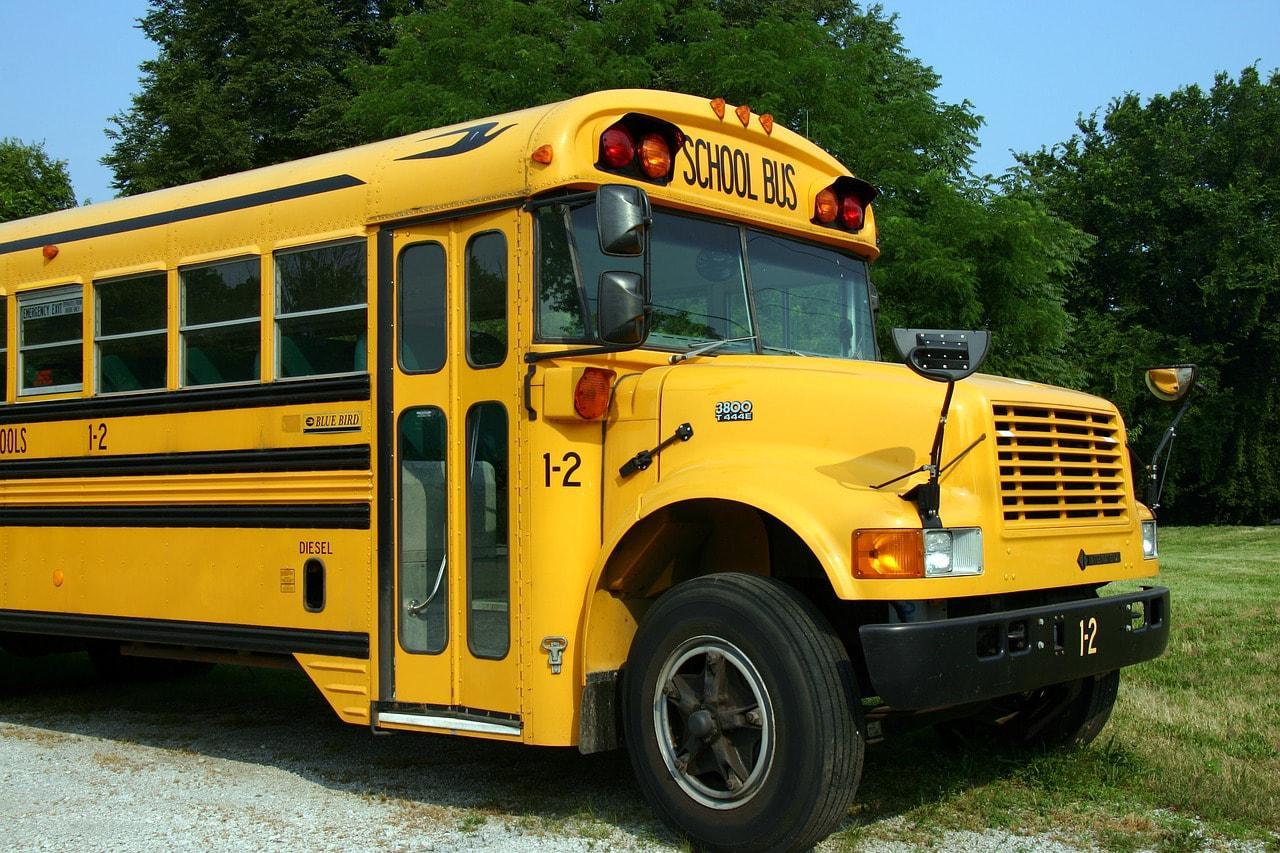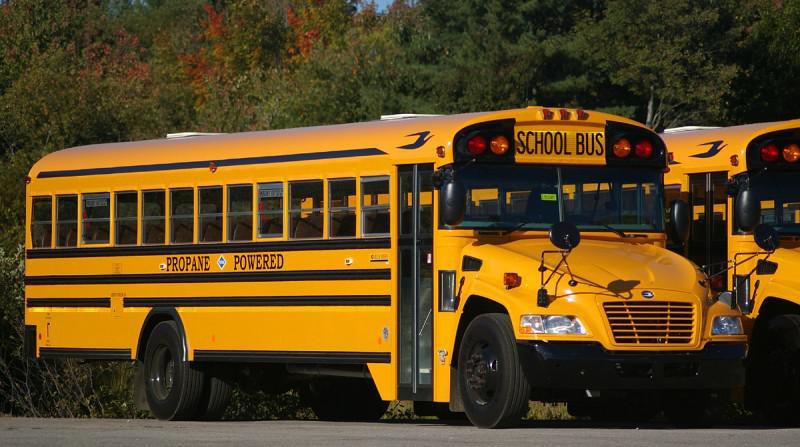The first image is the image on the left, the second image is the image on the right. Considering the images on both sides, is "Each image features an angled forward-facing bus, but the buses in the left and right images face opposite directions." valid? Answer yes or no. No. 